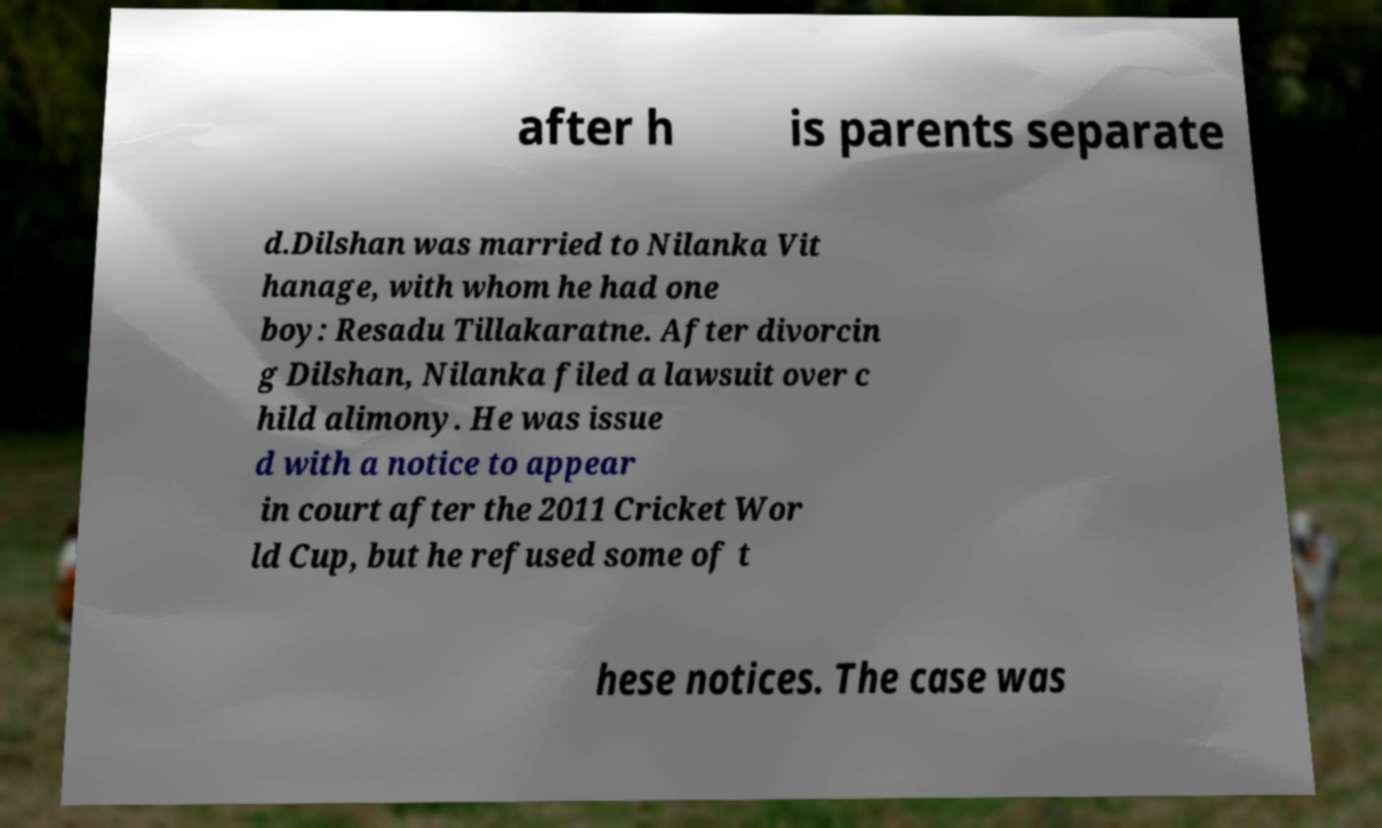Please identify and transcribe the text found in this image. after h is parents separate d.Dilshan was married to Nilanka Vit hanage, with whom he had one boy: Resadu Tillakaratne. After divorcin g Dilshan, Nilanka filed a lawsuit over c hild alimony. He was issue d with a notice to appear in court after the 2011 Cricket Wor ld Cup, but he refused some of t hese notices. The case was 